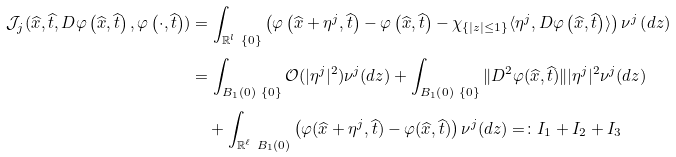Convert formula to latex. <formula><loc_0><loc_0><loc_500><loc_500>\mathcal { J } _ { j } ( \widehat { x } , \widehat { t } , D \varphi \left ( \widehat { x } , \widehat { t } \right ) , \varphi \left ( \cdot , \widehat { t } \right ) ) & = \int _ { \mathbb { R } ^ { l } \ \{ 0 \} } \left ( \varphi \left ( \widehat { x } + \eta ^ { j } , \widehat { t } \right ) - \varphi \left ( \widehat { x } , \widehat { t } \right ) - \chi _ { \{ | z | \leq 1 \} } \langle \eta ^ { j } , D \varphi \left ( \widehat { x } , \widehat { t } \right ) \rangle \right ) \nu ^ { j } \left ( d z \right ) \\ & = \int _ { B _ { 1 } \left ( 0 \right ) \ \{ 0 \} } \mathcal { O } ( | \eta ^ { j } | ^ { 2 } ) \nu ^ { j } ( d z ) + \int _ { B _ { 1 } \left ( 0 \right ) \ \{ 0 \} } \| D ^ { 2 } \varphi ( \widehat { x } , \widehat { t } ) \| | \eta ^ { j } | ^ { 2 } \nu ^ { j } ( d z ) \\ & \quad + \int _ { \mathbb { R } ^ { \ell } \ B _ { 1 } \left ( 0 \right ) } \left ( \varphi ( \widehat { x } + \eta ^ { j } , \widehat { t } ) - \varphi ( \widehat { x } , \widehat { t } ) \right ) \nu ^ { j } ( d z ) = \colon I _ { 1 } + I _ { 2 } + I _ { 3 }</formula> 